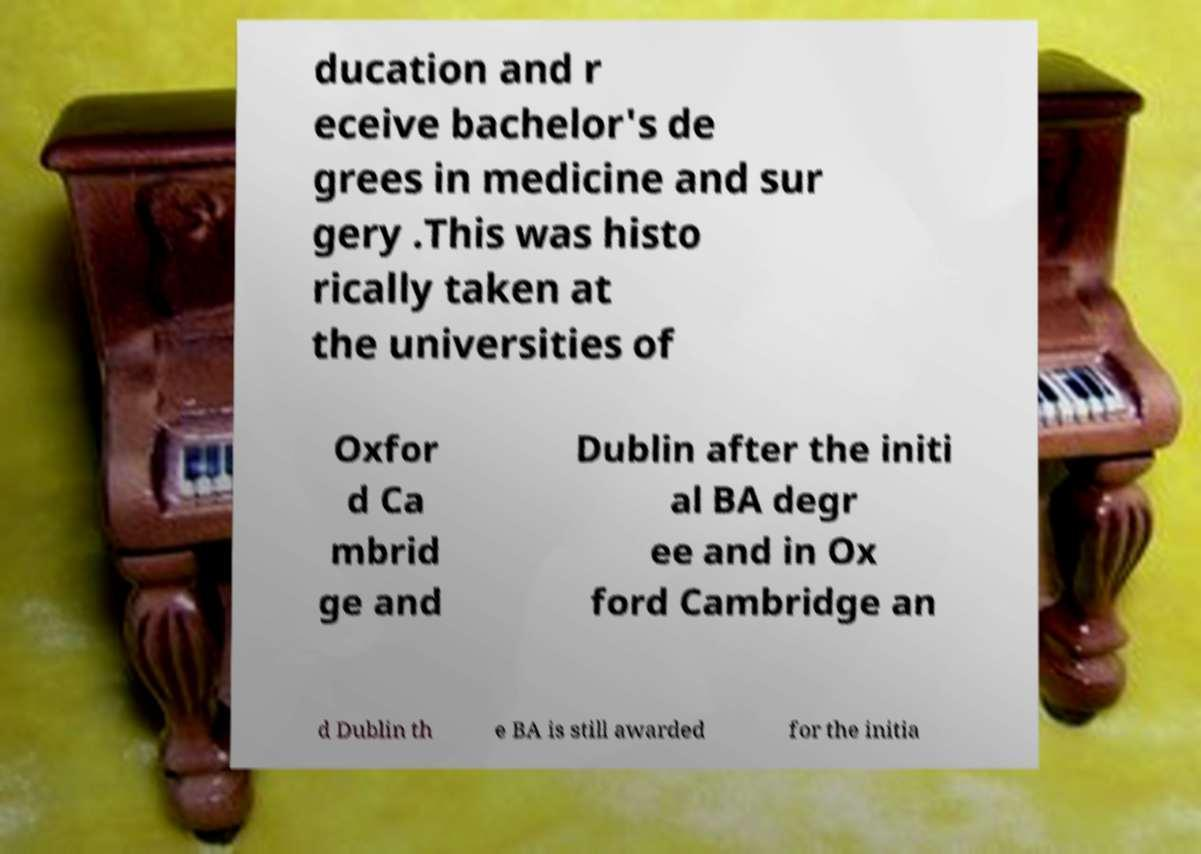Can you accurately transcribe the text from the provided image for me? ducation and r eceive bachelor's de grees in medicine and sur gery .This was histo rically taken at the universities of Oxfor d Ca mbrid ge and Dublin after the initi al BA degr ee and in Ox ford Cambridge an d Dublin th e BA is still awarded for the initia 